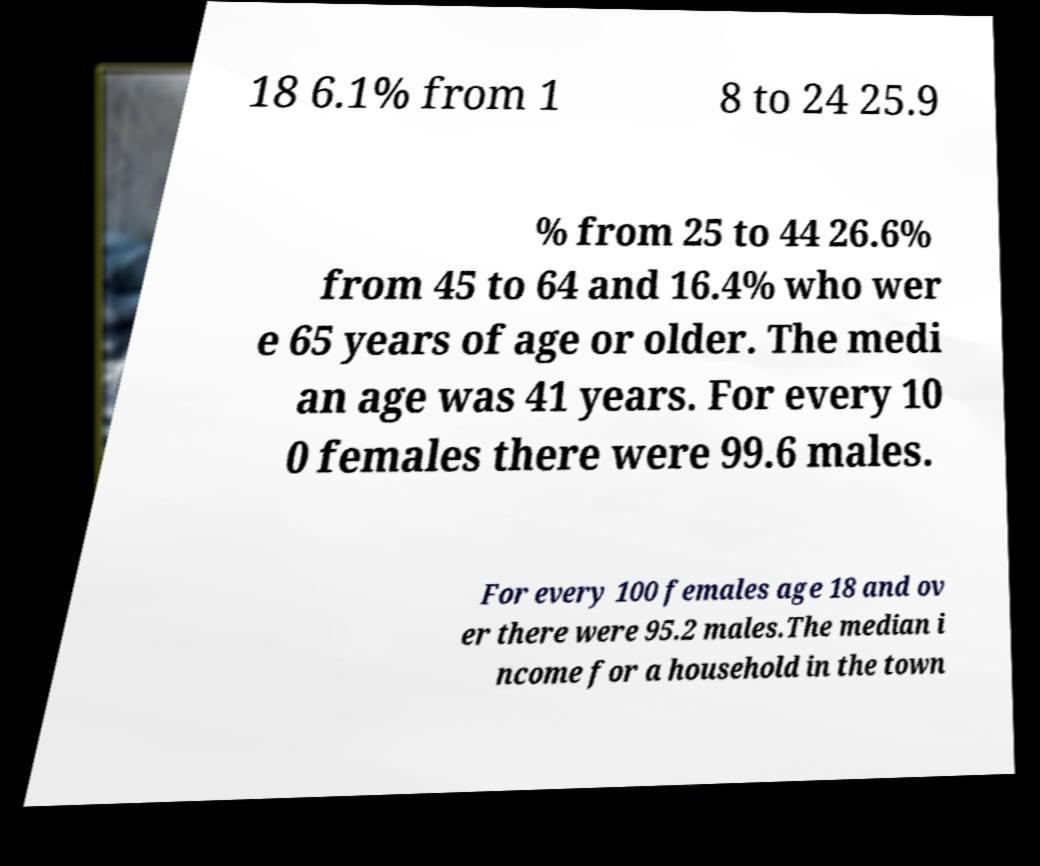Can you accurately transcribe the text from the provided image for me? 18 6.1% from 1 8 to 24 25.9 % from 25 to 44 26.6% from 45 to 64 and 16.4% who wer e 65 years of age or older. The medi an age was 41 years. For every 10 0 females there were 99.6 males. For every 100 females age 18 and ov er there were 95.2 males.The median i ncome for a household in the town 